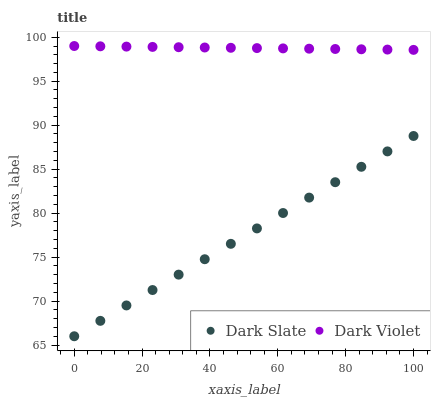Does Dark Slate have the minimum area under the curve?
Answer yes or no. Yes. Does Dark Violet have the maximum area under the curve?
Answer yes or no. Yes. Does Dark Violet have the minimum area under the curve?
Answer yes or no. No. Is Dark Violet the smoothest?
Answer yes or no. Yes. Is Dark Slate the roughest?
Answer yes or no. Yes. Is Dark Violet the roughest?
Answer yes or no. No. Does Dark Slate have the lowest value?
Answer yes or no. Yes. Does Dark Violet have the lowest value?
Answer yes or no. No. Does Dark Violet have the highest value?
Answer yes or no. Yes. Is Dark Slate less than Dark Violet?
Answer yes or no. Yes. Is Dark Violet greater than Dark Slate?
Answer yes or no. Yes. Does Dark Slate intersect Dark Violet?
Answer yes or no. No. 